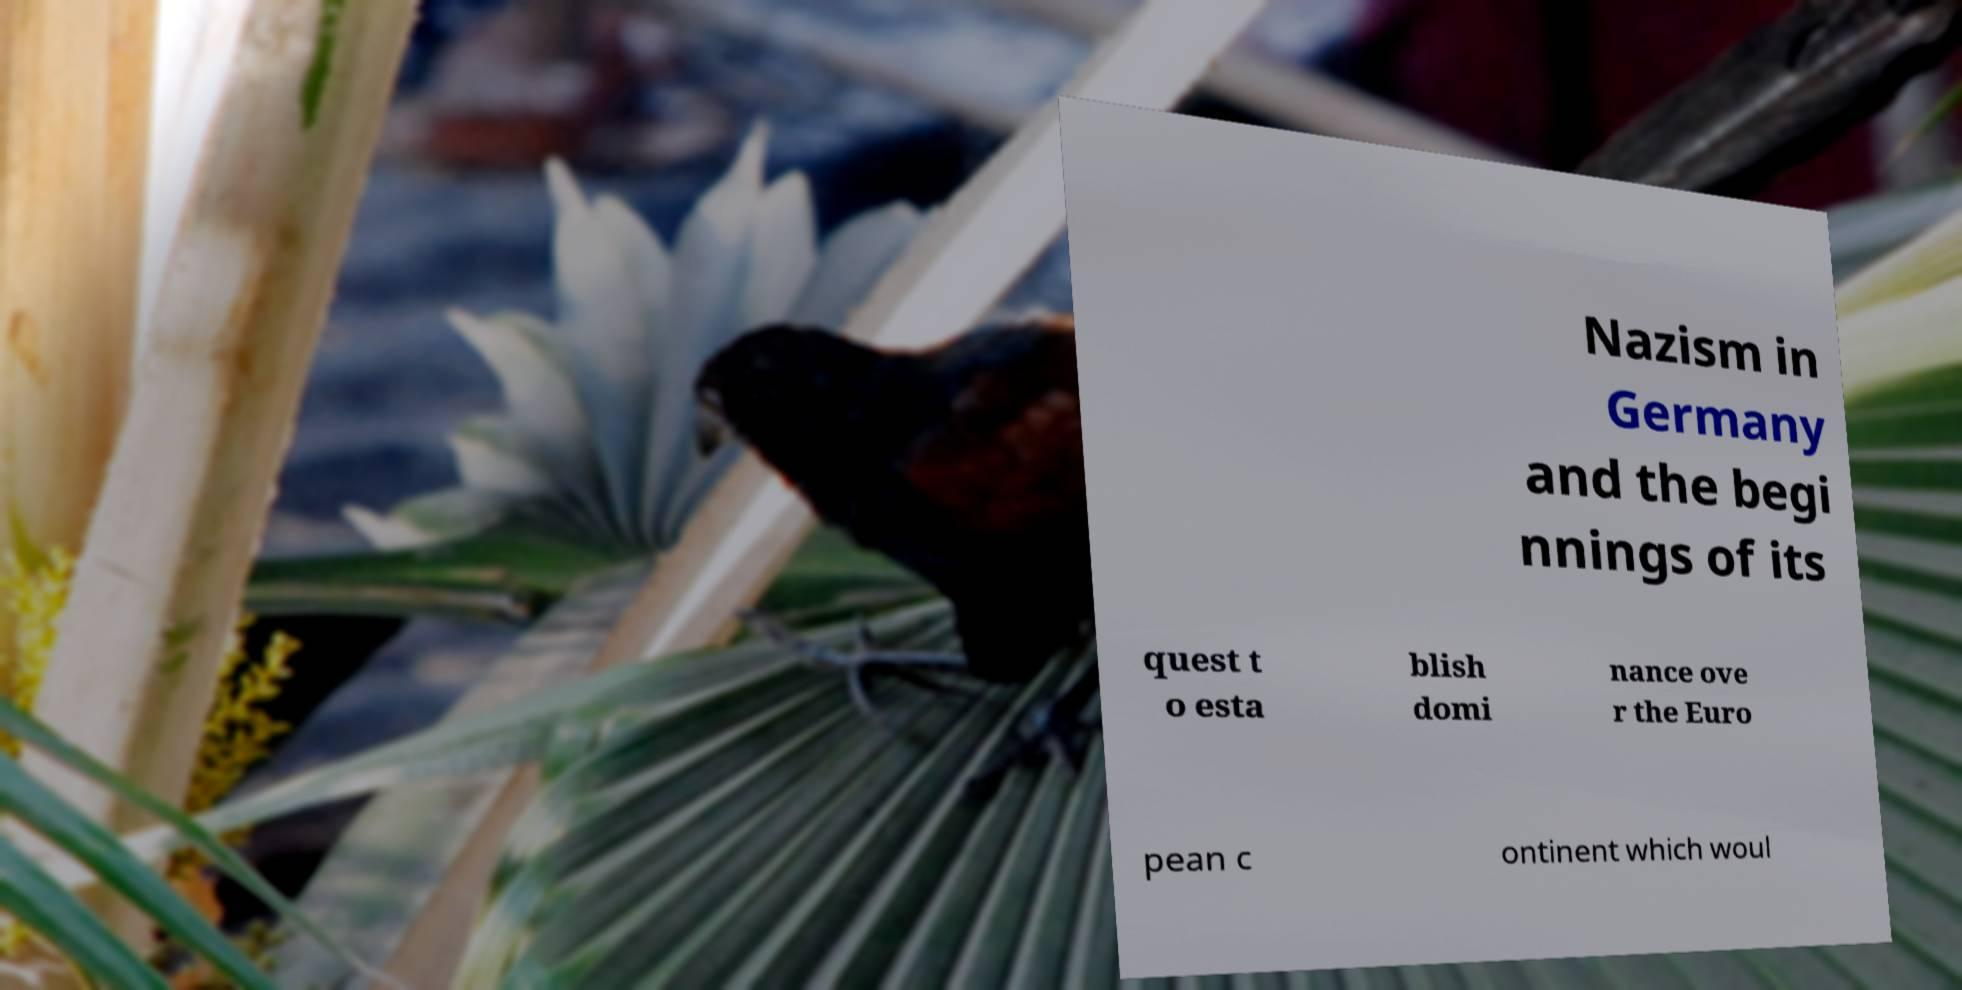Could you extract and type out the text from this image? Nazism in Germany and the begi nnings of its quest t o esta blish domi nance ove r the Euro pean c ontinent which woul 